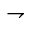Convert formula to latex. <formula><loc_0><loc_0><loc_500><loc_500>\rightharpoondown</formula> 